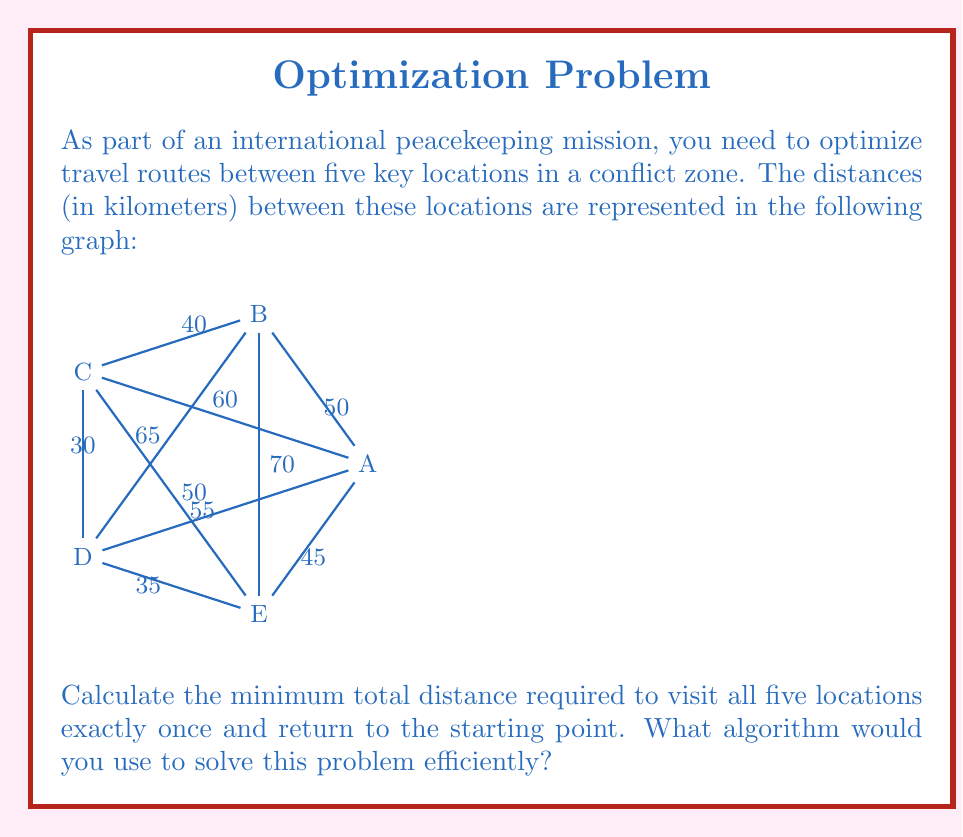Can you solve this math problem? This problem is an instance of the Traveling Salesman Problem (TSP), which is known to be NP-hard. For a small number of locations like in this case, we can use a brute-force approach to find the optimal solution.

Steps to solve:

1) Identify the problem: This is a TSP with 5 locations (vertices) and undirected edges with given weights (distances).

2) Calculate the total number of possible routes:
   - There are (5-1)! = 24 possible routes (we fix the starting point and permute the rest)

3) List all possible routes and calculate their total distances:
   A-B-C-D-E-A: 50 + 40 + 30 + 35 + 45 = 200
   A-B-C-E-D-A: 50 + 40 + 50 + 35 + 55 = 230
   A-B-D-C-E-A: 50 + 65 + 30 + 50 + 45 = 240
   A-B-D-E-C-A: 50 + 65 + 35 + 50 + 60 = 260
   A-B-E-C-D-A: 50 + 70 + 50 + 30 + 55 = 255
   A-B-E-D-C-A: 50 + 70 + 35 + 30 + 60 = 245
   ...
   (Continue for all 24 permutations)

4) Find the minimum total distance among all routes.

5) For efficient solving with larger datasets, we would use more advanced algorithms such as:
   - Dynamic Programming
   - Branch and Bound
   - Genetic Algorithms
   - Ant Colony Optimization

These algorithms can provide exact or near-optimal solutions in reasonable time for larger instances of the TSP.

In this case, the minimum distance route is A-B-C-D-E-A with a total distance of 200 km.
Answer: 200 km; Brute-force for small instances, advanced algorithms (e.g., Dynamic Programming, Branch and Bound) for larger datasets. 